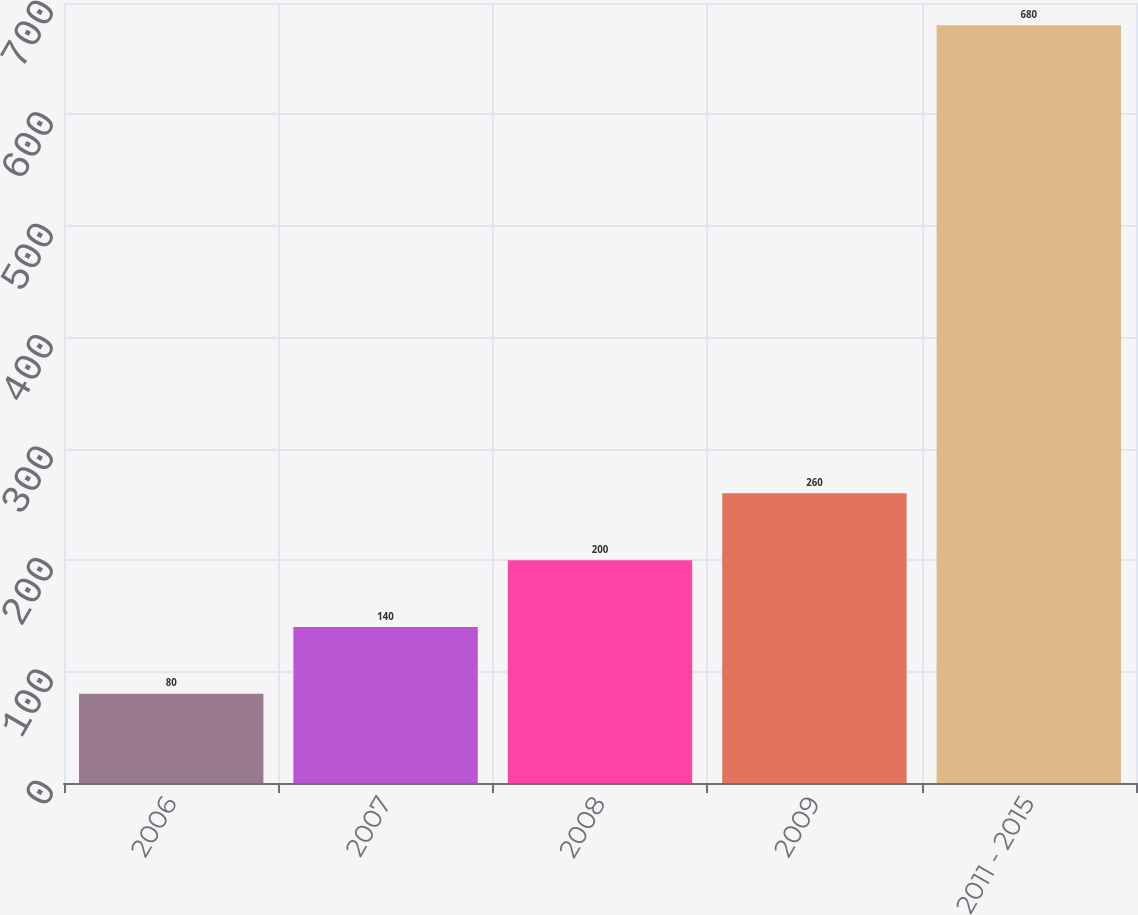Convert chart. <chart><loc_0><loc_0><loc_500><loc_500><bar_chart><fcel>2006<fcel>2007<fcel>2008<fcel>2009<fcel>2011 - 2015<nl><fcel>80<fcel>140<fcel>200<fcel>260<fcel>680<nl></chart> 